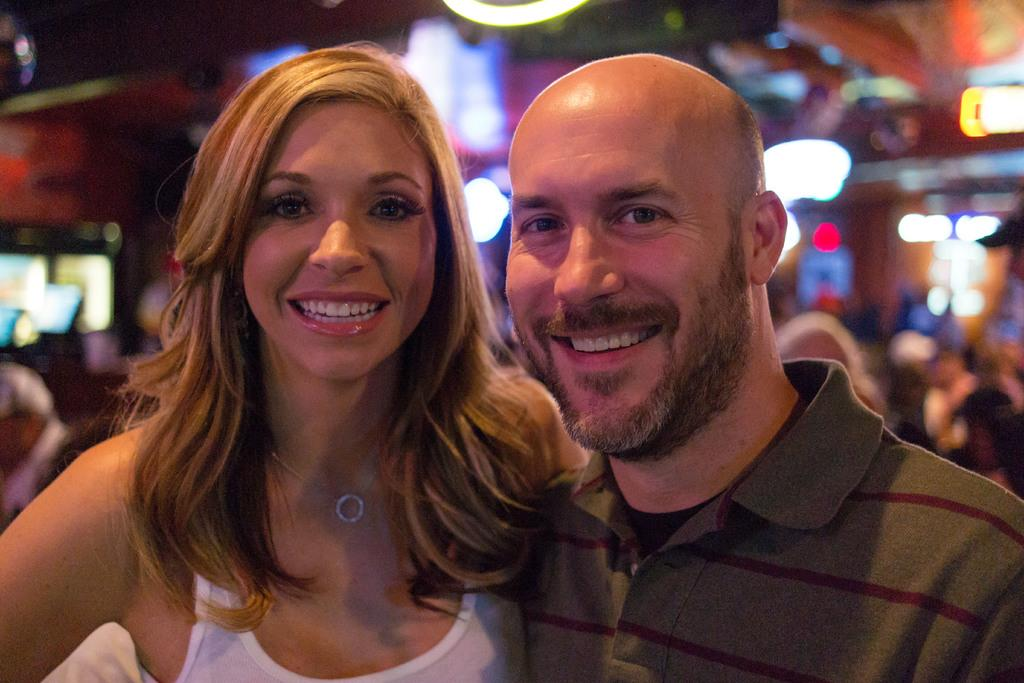Who can be seen in the foreground of the image? There is a couple in the foreground of the image. What are the couple doing in the image? The couple is standing in the image. What expression do the couple have in the image? The couple is smiling in the image. What can be seen in the background of the image? There is a blurred image in the background of the image. Where is the bed located in the image? There is no bed present in the image. What is the couple resting on in the image? The couple is standing, not resting, in the image. 